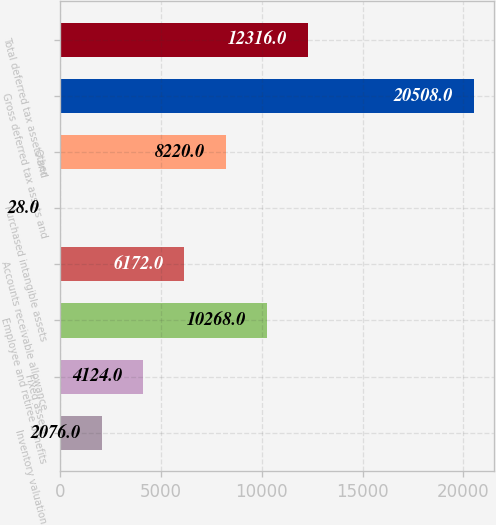Convert chart. <chart><loc_0><loc_0><loc_500><loc_500><bar_chart><fcel>Inventory valuation<fcel>Fixed assets<fcel>Employee and retiree benefits<fcel>Accounts receivable allowance<fcel>Purchased intangible assets<fcel>Other<fcel>Gross deferred tax assets and<fcel>Total deferred tax assets and<nl><fcel>2076<fcel>4124<fcel>10268<fcel>6172<fcel>28<fcel>8220<fcel>20508<fcel>12316<nl></chart> 